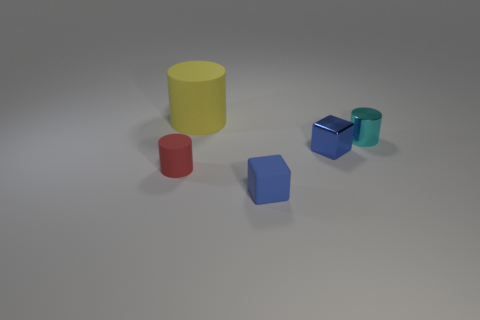What shape is the small metal thing that is the same color as the small matte block?
Keep it short and to the point. Cube. How many other things are there of the same color as the rubber block?
Your response must be concise. 1. Is the number of tiny things that are on the right side of the yellow cylinder greater than the number of small cubes?
Offer a very short reply. Yes. Does the small red object have the same material as the cyan cylinder?
Keep it short and to the point. No. What number of things are either matte objects that are behind the tiny red cylinder or small red rubber objects?
Give a very brief answer. 2. What number of other objects are there of the same size as the blue rubber block?
Offer a terse response. 3. Is the number of tiny cylinders to the left of the small matte block the same as the number of large things left of the small red object?
Provide a short and direct response. No. What color is the other thing that is the same shape as the small blue rubber object?
Your response must be concise. Blue. There is a matte cylinder that is to the left of the big cylinder; does it have the same color as the tiny shiny cylinder?
Your answer should be compact. No. There is a cyan metallic thing that is the same shape as the large yellow matte object; what size is it?
Your answer should be compact. Small. 